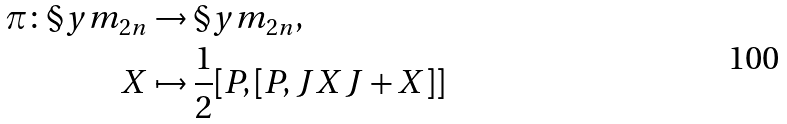<formula> <loc_0><loc_0><loc_500><loc_500>\pi \colon \S y m _ { 2 n } & \to \S y m _ { 2 n } , \\ X & \mapsto \frac { 1 } { 2 } [ P , [ P , J X J + X ] ]</formula> 